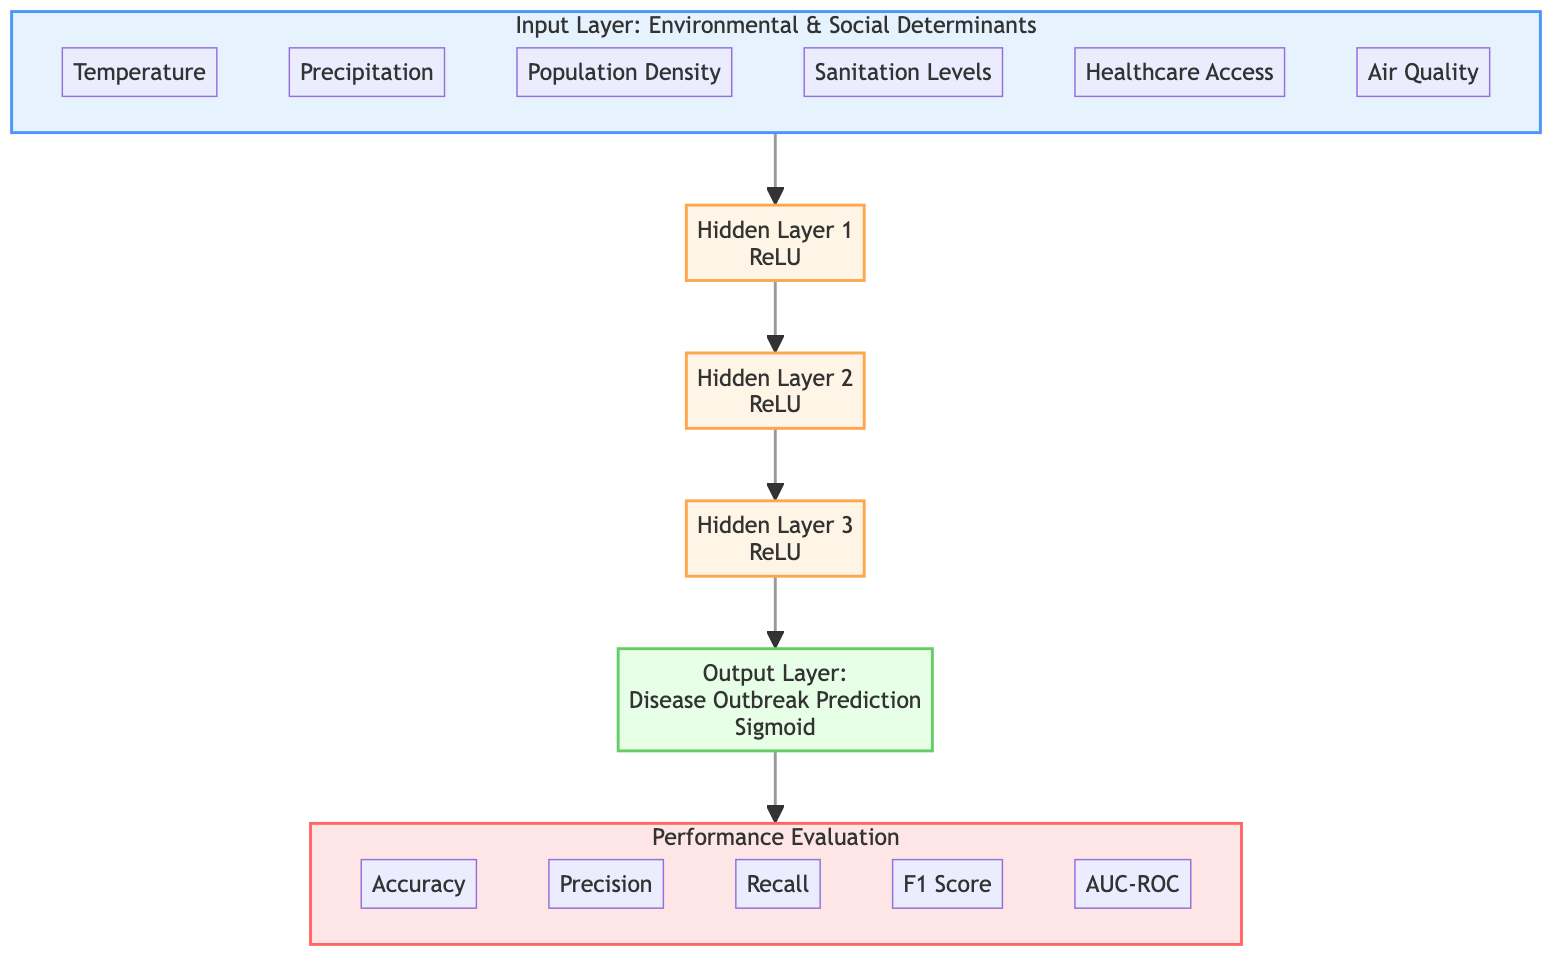What are the inputs for the model? The inputs for the model are Temperature, Precipitation, Population Density, Sanitation Levels, Healthcare Access, and Air Quality. These are listed in the Input Layer section of the diagram.
Answer: Temperature, Precipitation, Population Density, Sanitation Levels, Healthcare Access, Air Quality How many hidden layers are present in the diagram? The diagram contains three hidden layers as indicated by the nodes labeled Hidden Layer 1, Hidden Layer 2, and Hidden Layer 3.
Answer: 3 What activation function is used in the output layer? The output layer utilizes the Sigmoid activation function, as specified at the node of the Output Layer in the diagram.
Answer: Sigmoid Which evaluation metric is among the performance evaluations? The metrics listed in the Performance Evaluation subgraph include Accuracy, Precision, Recall, F1 Score, and AUC-ROC. One of the evaluation metrics is Precision.
Answer: Precision What is the activation function used in all hidden layers? All hidden layers use the ReLU activation function as indicated at each hidden layer node in the diagram.
Answer: ReLU How many total nodes are there in the hidden layer section? There are three hidden layers, each represented by a single node, totaling three nodes in the hidden layer section of the diagram.
Answer: 3 What is the flow direction from the inputs to the output? The flow direction moves from the Input Layer through the three hidden layers to the Output Layer, indicating a sequential process in predicting disease outbreaks.
Answer: Forward What is the final output of the model? The final output of the model is Disease Outbreak Prediction as stated in the Output Layer node of the diagram.
Answer: Disease Outbreak Prediction What is the first evaluation metric listed? The first evaluation metric listed in the Performance Evaluation subgraph is Accuracy, as shown in the diagram.
Answer: Accuracy 